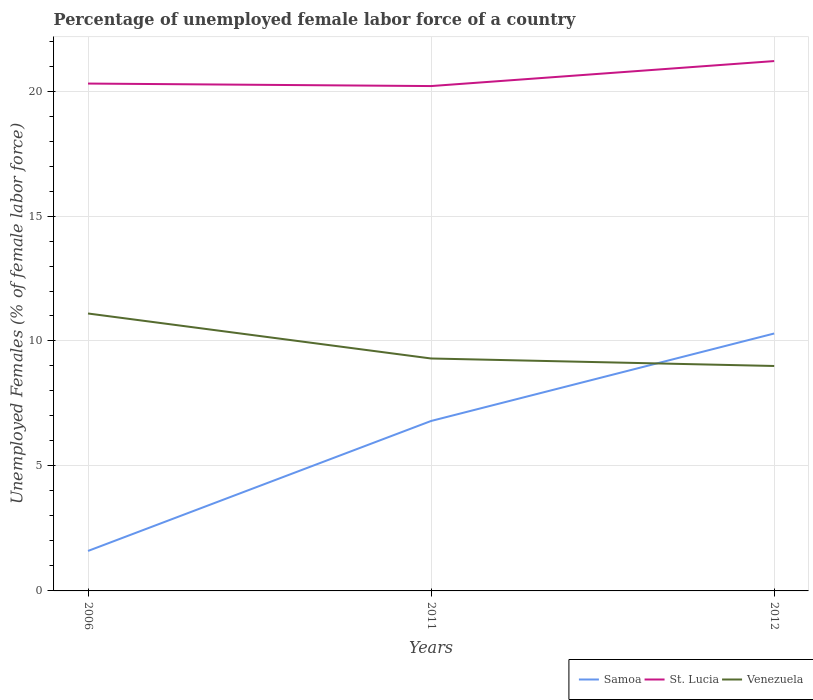How many different coloured lines are there?
Make the answer very short. 3. Across all years, what is the maximum percentage of unemployed female labor force in Samoa?
Make the answer very short. 1.6. In which year was the percentage of unemployed female labor force in Venezuela maximum?
Your answer should be compact. 2012. What is the total percentage of unemployed female labor force in Venezuela in the graph?
Give a very brief answer. 0.3. What is the difference between the highest and the second highest percentage of unemployed female labor force in Venezuela?
Make the answer very short. 2.1. How many years are there in the graph?
Give a very brief answer. 3. Are the values on the major ticks of Y-axis written in scientific E-notation?
Give a very brief answer. No. Does the graph contain grids?
Your answer should be compact. Yes. How are the legend labels stacked?
Offer a very short reply. Horizontal. What is the title of the graph?
Keep it short and to the point. Percentage of unemployed female labor force of a country. Does "Bolivia" appear as one of the legend labels in the graph?
Provide a short and direct response. No. What is the label or title of the Y-axis?
Give a very brief answer. Unemployed Females (% of female labor force). What is the Unemployed Females (% of female labor force) of Samoa in 2006?
Make the answer very short. 1.6. What is the Unemployed Females (% of female labor force) in St. Lucia in 2006?
Offer a very short reply. 20.3. What is the Unemployed Females (% of female labor force) in Venezuela in 2006?
Offer a terse response. 11.1. What is the Unemployed Females (% of female labor force) of Samoa in 2011?
Make the answer very short. 6.8. What is the Unemployed Females (% of female labor force) in St. Lucia in 2011?
Ensure brevity in your answer.  20.2. What is the Unemployed Females (% of female labor force) in Venezuela in 2011?
Your answer should be very brief. 9.3. What is the Unemployed Females (% of female labor force) in Samoa in 2012?
Your answer should be very brief. 10.3. What is the Unemployed Females (% of female labor force) in St. Lucia in 2012?
Make the answer very short. 21.2. Across all years, what is the maximum Unemployed Females (% of female labor force) in Samoa?
Your response must be concise. 10.3. Across all years, what is the maximum Unemployed Females (% of female labor force) of St. Lucia?
Offer a terse response. 21.2. Across all years, what is the maximum Unemployed Females (% of female labor force) in Venezuela?
Your answer should be compact. 11.1. Across all years, what is the minimum Unemployed Females (% of female labor force) in Samoa?
Your response must be concise. 1.6. Across all years, what is the minimum Unemployed Females (% of female labor force) in St. Lucia?
Your answer should be compact. 20.2. Across all years, what is the minimum Unemployed Females (% of female labor force) of Venezuela?
Provide a short and direct response. 9. What is the total Unemployed Females (% of female labor force) in St. Lucia in the graph?
Give a very brief answer. 61.7. What is the total Unemployed Females (% of female labor force) of Venezuela in the graph?
Make the answer very short. 29.4. What is the difference between the Unemployed Females (% of female labor force) in Samoa in 2006 and that in 2012?
Offer a very short reply. -8.7. What is the difference between the Unemployed Females (% of female labor force) in St. Lucia in 2006 and that in 2012?
Provide a short and direct response. -0.9. What is the difference between the Unemployed Females (% of female labor force) of Samoa in 2011 and that in 2012?
Offer a terse response. -3.5. What is the difference between the Unemployed Females (% of female labor force) in Venezuela in 2011 and that in 2012?
Give a very brief answer. 0.3. What is the difference between the Unemployed Females (% of female labor force) in Samoa in 2006 and the Unemployed Females (% of female labor force) in St. Lucia in 2011?
Make the answer very short. -18.6. What is the difference between the Unemployed Females (% of female labor force) of Samoa in 2006 and the Unemployed Females (% of female labor force) of Venezuela in 2011?
Your response must be concise. -7.7. What is the difference between the Unemployed Females (% of female labor force) of St. Lucia in 2006 and the Unemployed Females (% of female labor force) of Venezuela in 2011?
Your answer should be very brief. 11. What is the difference between the Unemployed Females (% of female labor force) of Samoa in 2006 and the Unemployed Females (% of female labor force) of St. Lucia in 2012?
Provide a short and direct response. -19.6. What is the difference between the Unemployed Females (% of female labor force) of Samoa in 2011 and the Unemployed Females (% of female labor force) of St. Lucia in 2012?
Your answer should be very brief. -14.4. What is the difference between the Unemployed Females (% of female labor force) of Samoa in 2011 and the Unemployed Females (% of female labor force) of Venezuela in 2012?
Ensure brevity in your answer.  -2.2. What is the average Unemployed Females (% of female labor force) in Samoa per year?
Make the answer very short. 6.23. What is the average Unemployed Females (% of female labor force) in St. Lucia per year?
Your response must be concise. 20.57. In the year 2006, what is the difference between the Unemployed Females (% of female labor force) in Samoa and Unemployed Females (% of female labor force) in St. Lucia?
Your response must be concise. -18.7. In the year 2006, what is the difference between the Unemployed Females (% of female labor force) of St. Lucia and Unemployed Females (% of female labor force) of Venezuela?
Your answer should be compact. 9.2. In the year 2011, what is the difference between the Unemployed Females (% of female labor force) of Samoa and Unemployed Females (% of female labor force) of St. Lucia?
Offer a terse response. -13.4. What is the ratio of the Unemployed Females (% of female labor force) in Samoa in 2006 to that in 2011?
Provide a short and direct response. 0.24. What is the ratio of the Unemployed Females (% of female labor force) of Venezuela in 2006 to that in 2011?
Provide a succinct answer. 1.19. What is the ratio of the Unemployed Females (% of female labor force) in Samoa in 2006 to that in 2012?
Provide a succinct answer. 0.16. What is the ratio of the Unemployed Females (% of female labor force) of St. Lucia in 2006 to that in 2012?
Your answer should be very brief. 0.96. What is the ratio of the Unemployed Females (% of female labor force) of Venezuela in 2006 to that in 2012?
Your answer should be compact. 1.23. What is the ratio of the Unemployed Females (% of female labor force) in Samoa in 2011 to that in 2012?
Offer a terse response. 0.66. What is the ratio of the Unemployed Females (% of female labor force) in St. Lucia in 2011 to that in 2012?
Your answer should be compact. 0.95. What is the ratio of the Unemployed Females (% of female labor force) in Venezuela in 2011 to that in 2012?
Your answer should be compact. 1.03. What is the difference between the highest and the second highest Unemployed Females (% of female labor force) of Venezuela?
Your answer should be compact. 1.8. What is the difference between the highest and the lowest Unemployed Females (% of female labor force) of Samoa?
Provide a succinct answer. 8.7. 